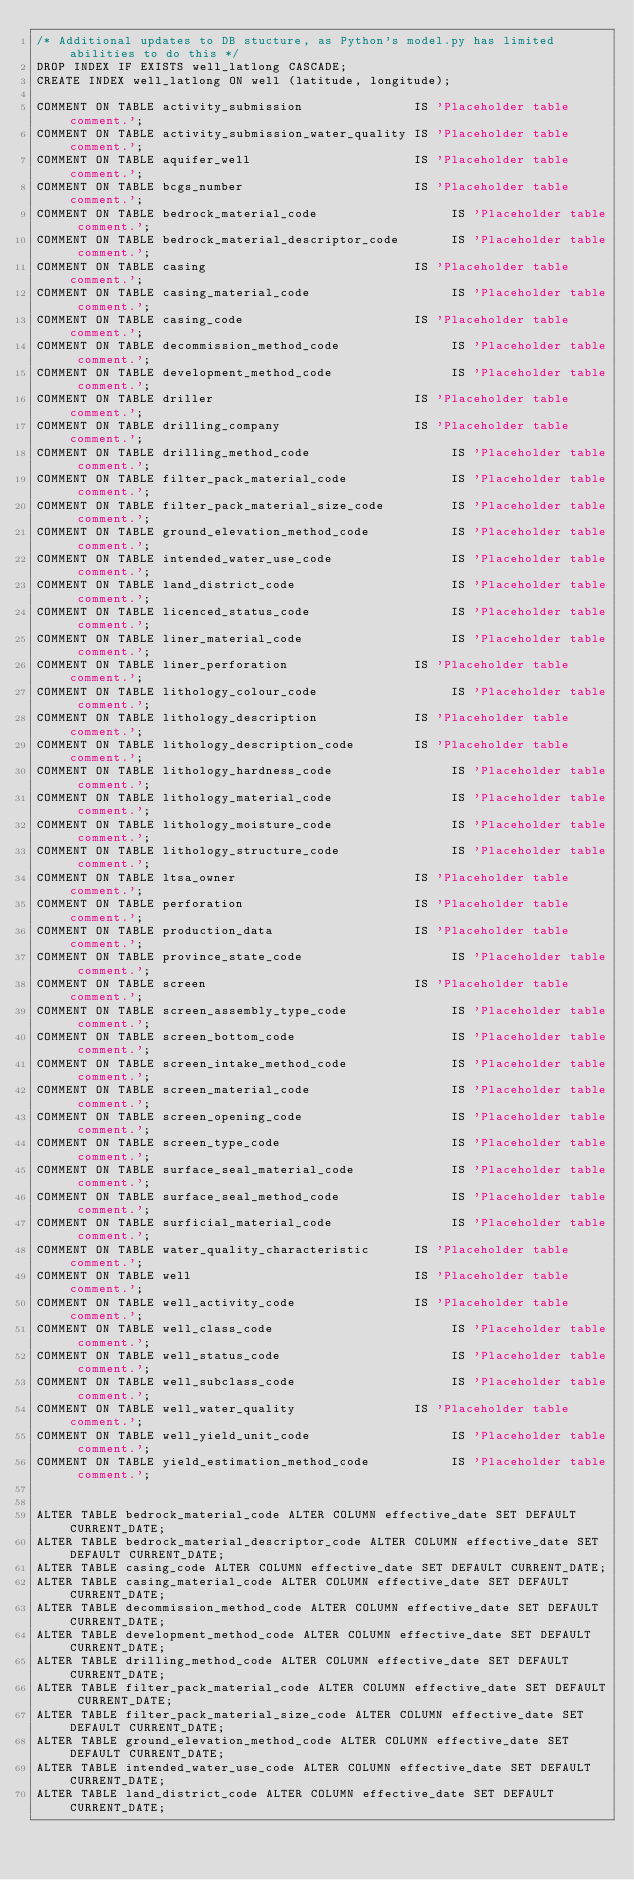Convert code to text. <code><loc_0><loc_0><loc_500><loc_500><_SQL_>/* Additional updates to DB stucture, as Python's model.py has limited abilities to do this */
DROP INDEX IF EXISTS well_latlong CASCADE;
CREATE INDEX well_latlong ON well (latitude, longitude);

COMMENT ON TABLE activity_submission               IS 'Placeholder table comment.';
COMMENT ON TABLE activity_submission_water_quality IS 'Placeholder table comment.';
COMMENT ON TABLE aquifer_well                      IS 'Placeholder table comment.';
COMMENT ON TABLE bcgs_number                       IS 'Placeholder table comment.';
COMMENT ON TABLE bedrock_material_code                  IS 'Placeholder table comment.';
COMMENT ON TABLE bedrock_material_descriptor_code       IS 'Placeholder table comment.';
COMMENT ON TABLE casing                            IS 'Placeholder table comment.';
COMMENT ON TABLE casing_material_code                   IS 'Placeholder table comment.';
COMMENT ON TABLE casing_code                       IS 'Placeholder table comment.';
COMMENT ON TABLE decommission_method_code               IS 'Placeholder table comment.';
COMMENT ON TABLE development_method_code                IS 'Placeholder table comment.';
COMMENT ON TABLE driller                           IS 'Placeholder table comment.';
COMMENT ON TABLE drilling_company                  IS 'Placeholder table comment.';
COMMENT ON TABLE drilling_method_code                   IS 'Placeholder table comment.';
COMMENT ON TABLE filter_pack_material_code              IS 'Placeholder table comment.';
COMMENT ON TABLE filter_pack_material_size_code         IS 'Placeholder table comment.';
COMMENT ON TABLE ground_elevation_method_code           IS 'Placeholder table comment.';
COMMENT ON TABLE intended_water_use_code                IS 'Placeholder table comment.';
COMMENT ON TABLE land_district_code                     IS 'Placeholder table comment.';
COMMENT ON TABLE licenced_status_code                   IS 'Placeholder table comment.';
COMMENT ON TABLE liner_material_code                    IS 'Placeholder table comment.';
COMMENT ON TABLE liner_perforation                 IS 'Placeholder table comment.';
COMMENT ON TABLE lithology_colour_code                  IS 'Placeholder table comment.';
COMMENT ON TABLE lithology_description             IS 'Placeholder table comment.';
COMMENT ON TABLE lithology_description_code        IS 'Placeholder table comment.';
COMMENT ON TABLE lithology_hardness_code                IS 'Placeholder table comment.';
COMMENT ON TABLE lithology_material_code                IS 'Placeholder table comment.';
COMMENT ON TABLE lithology_moisture_code                IS 'Placeholder table comment.';
COMMENT ON TABLE lithology_structure_code               IS 'Placeholder table comment.';
COMMENT ON TABLE ltsa_owner                        IS 'Placeholder table comment.';
COMMENT ON TABLE perforation                       IS 'Placeholder table comment.';
COMMENT ON TABLE production_data                   IS 'Placeholder table comment.';
COMMENT ON TABLE province_state_code                    IS 'Placeholder table comment.';
COMMENT ON TABLE screen                            IS 'Placeholder table comment.';
COMMENT ON TABLE screen_assembly_type_code              IS 'Placeholder table comment.';
COMMENT ON TABLE screen_bottom_code                     IS 'Placeholder table comment.';
COMMENT ON TABLE screen_intake_method_code              IS 'Placeholder table comment.';
COMMENT ON TABLE screen_material_code                   IS 'Placeholder table comment.';
COMMENT ON TABLE screen_opening_code                    IS 'Placeholder table comment.';
COMMENT ON TABLE screen_type_code                       IS 'Placeholder table comment.';
COMMENT ON TABLE surface_seal_material_code             IS 'Placeholder table comment.';
COMMENT ON TABLE surface_seal_method_code               IS 'Placeholder table comment.';
COMMENT ON TABLE surficial_material_code                IS 'Placeholder table comment.';
COMMENT ON TABLE water_quality_characteristic      IS 'Placeholder table comment.';
COMMENT ON TABLE well                              IS 'Placeholder table comment.';
COMMENT ON TABLE well_activity_code                IS 'Placeholder table comment.';
COMMENT ON TABLE well_class_code                        IS 'Placeholder table comment.';
COMMENT ON TABLE well_status_code                       IS 'Placeholder table comment.';
COMMENT ON TABLE well_subclass_code                     IS 'Placeholder table comment.';
COMMENT ON TABLE well_water_quality                IS 'Placeholder table comment.';
COMMENT ON TABLE well_yield_unit_code                   IS 'Placeholder table comment.';
COMMENT ON TABLE yield_estimation_method_code           IS 'Placeholder table comment.';


ALTER TABLE bedrock_material_code ALTER COLUMN effective_date SET DEFAULT CURRENT_DATE;
ALTER TABLE bedrock_material_descriptor_code ALTER COLUMN effective_date SET DEFAULT CURRENT_DATE;
ALTER TABLE casing_code ALTER COLUMN effective_date SET DEFAULT CURRENT_DATE;
ALTER TABLE casing_material_code ALTER COLUMN effective_date SET DEFAULT CURRENT_DATE;
ALTER TABLE decommission_method_code ALTER COLUMN effective_date SET DEFAULT CURRENT_DATE;
ALTER TABLE development_method_code ALTER COLUMN effective_date SET DEFAULT CURRENT_DATE;
ALTER TABLE drilling_method_code ALTER COLUMN effective_date SET DEFAULT CURRENT_DATE;
ALTER TABLE filter_pack_material_code ALTER COLUMN effective_date SET DEFAULT CURRENT_DATE;
ALTER TABLE filter_pack_material_size_code ALTER COLUMN effective_date SET DEFAULT CURRENT_DATE;
ALTER TABLE ground_elevation_method_code ALTER COLUMN effective_date SET DEFAULT CURRENT_DATE;
ALTER TABLE intended_water_use_code ALTER COLUMN effective_date SET DEFAULT CURRENT_DATE;
ALTER TABLE land_district_code ALTER COLUMN effective_date SET DEFAULT CURRENT_DATE;</code> 